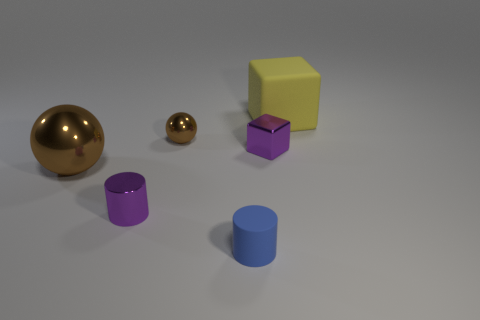The small brown object is what shape?
Give a very brief answer. Sphere. There is a rubber cylinder; are there any purple objects right of it?
Ensure brevity in your answer.  Yes. Does the yellow cube have the same material as the object in front of the tiny purple metal cylinder?
Your answer should be very brief. Yes. Do the brown object that is in front of the tiny brown shiny ball and the small brown shiny object have the same shape?
Your answer should be compact. Yes. What number of small brown objects have the same material as the yellow cube?
Offer a terse response. 0. How many objects are objects in front of the big metallic object or large objects?
Provide a succinct answer. 4. The metal block has what size?
Offer a terse response. Small. There is a sphere in front of the block that is in front of the big yellow matte block; what is its material?
Your answer should be very brief. Metal. Does the rubber object behind the purple metal cylinder have the same size as the large brown shiny ball?
Make the answer very short. Yes. Are there any objects of the same color as the large metal sphere?
Offer a terse response. Yes. 